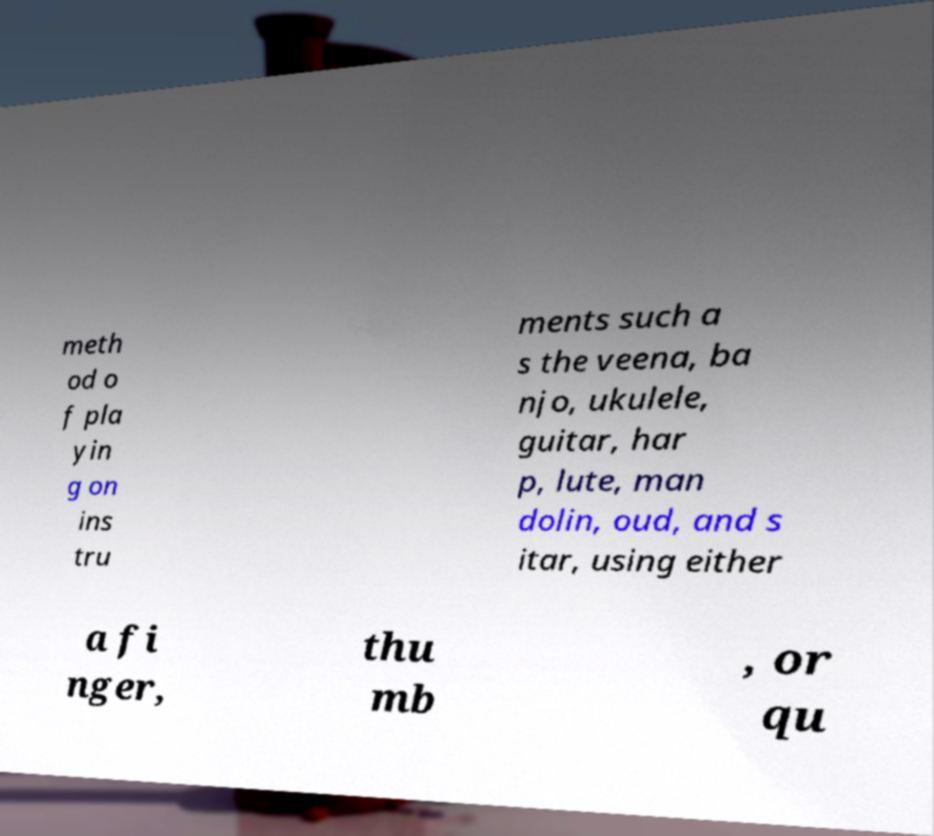There's text embedded in this image that I need extracted. Can you transcribe it verbatim? meth od o f pla yin g on ins tru ments such a s the veena, ba njo, ukulele, guitar, har p, lute, man dolin, oud, and s itar, using either a fi nger, thu mb , or qu 